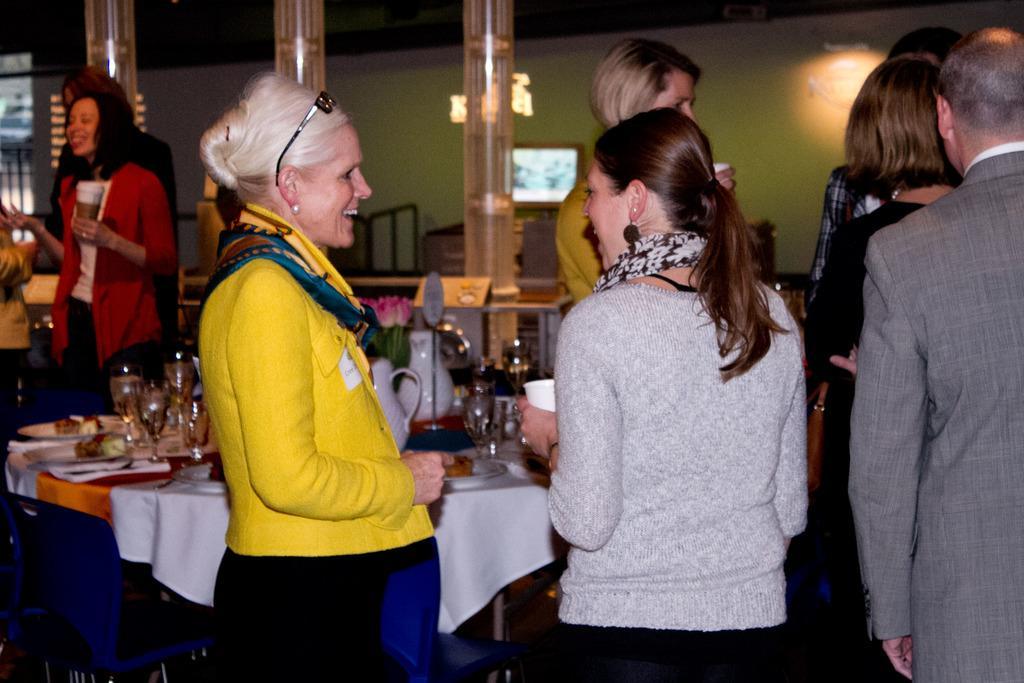Describe this image in one or two sentences. In the center of the image we can see people standing. At the bottom there is a table and we can see plates, glasses, jars and a flower bouquet placed on the table. In the background there is a wall and we can see a light. 